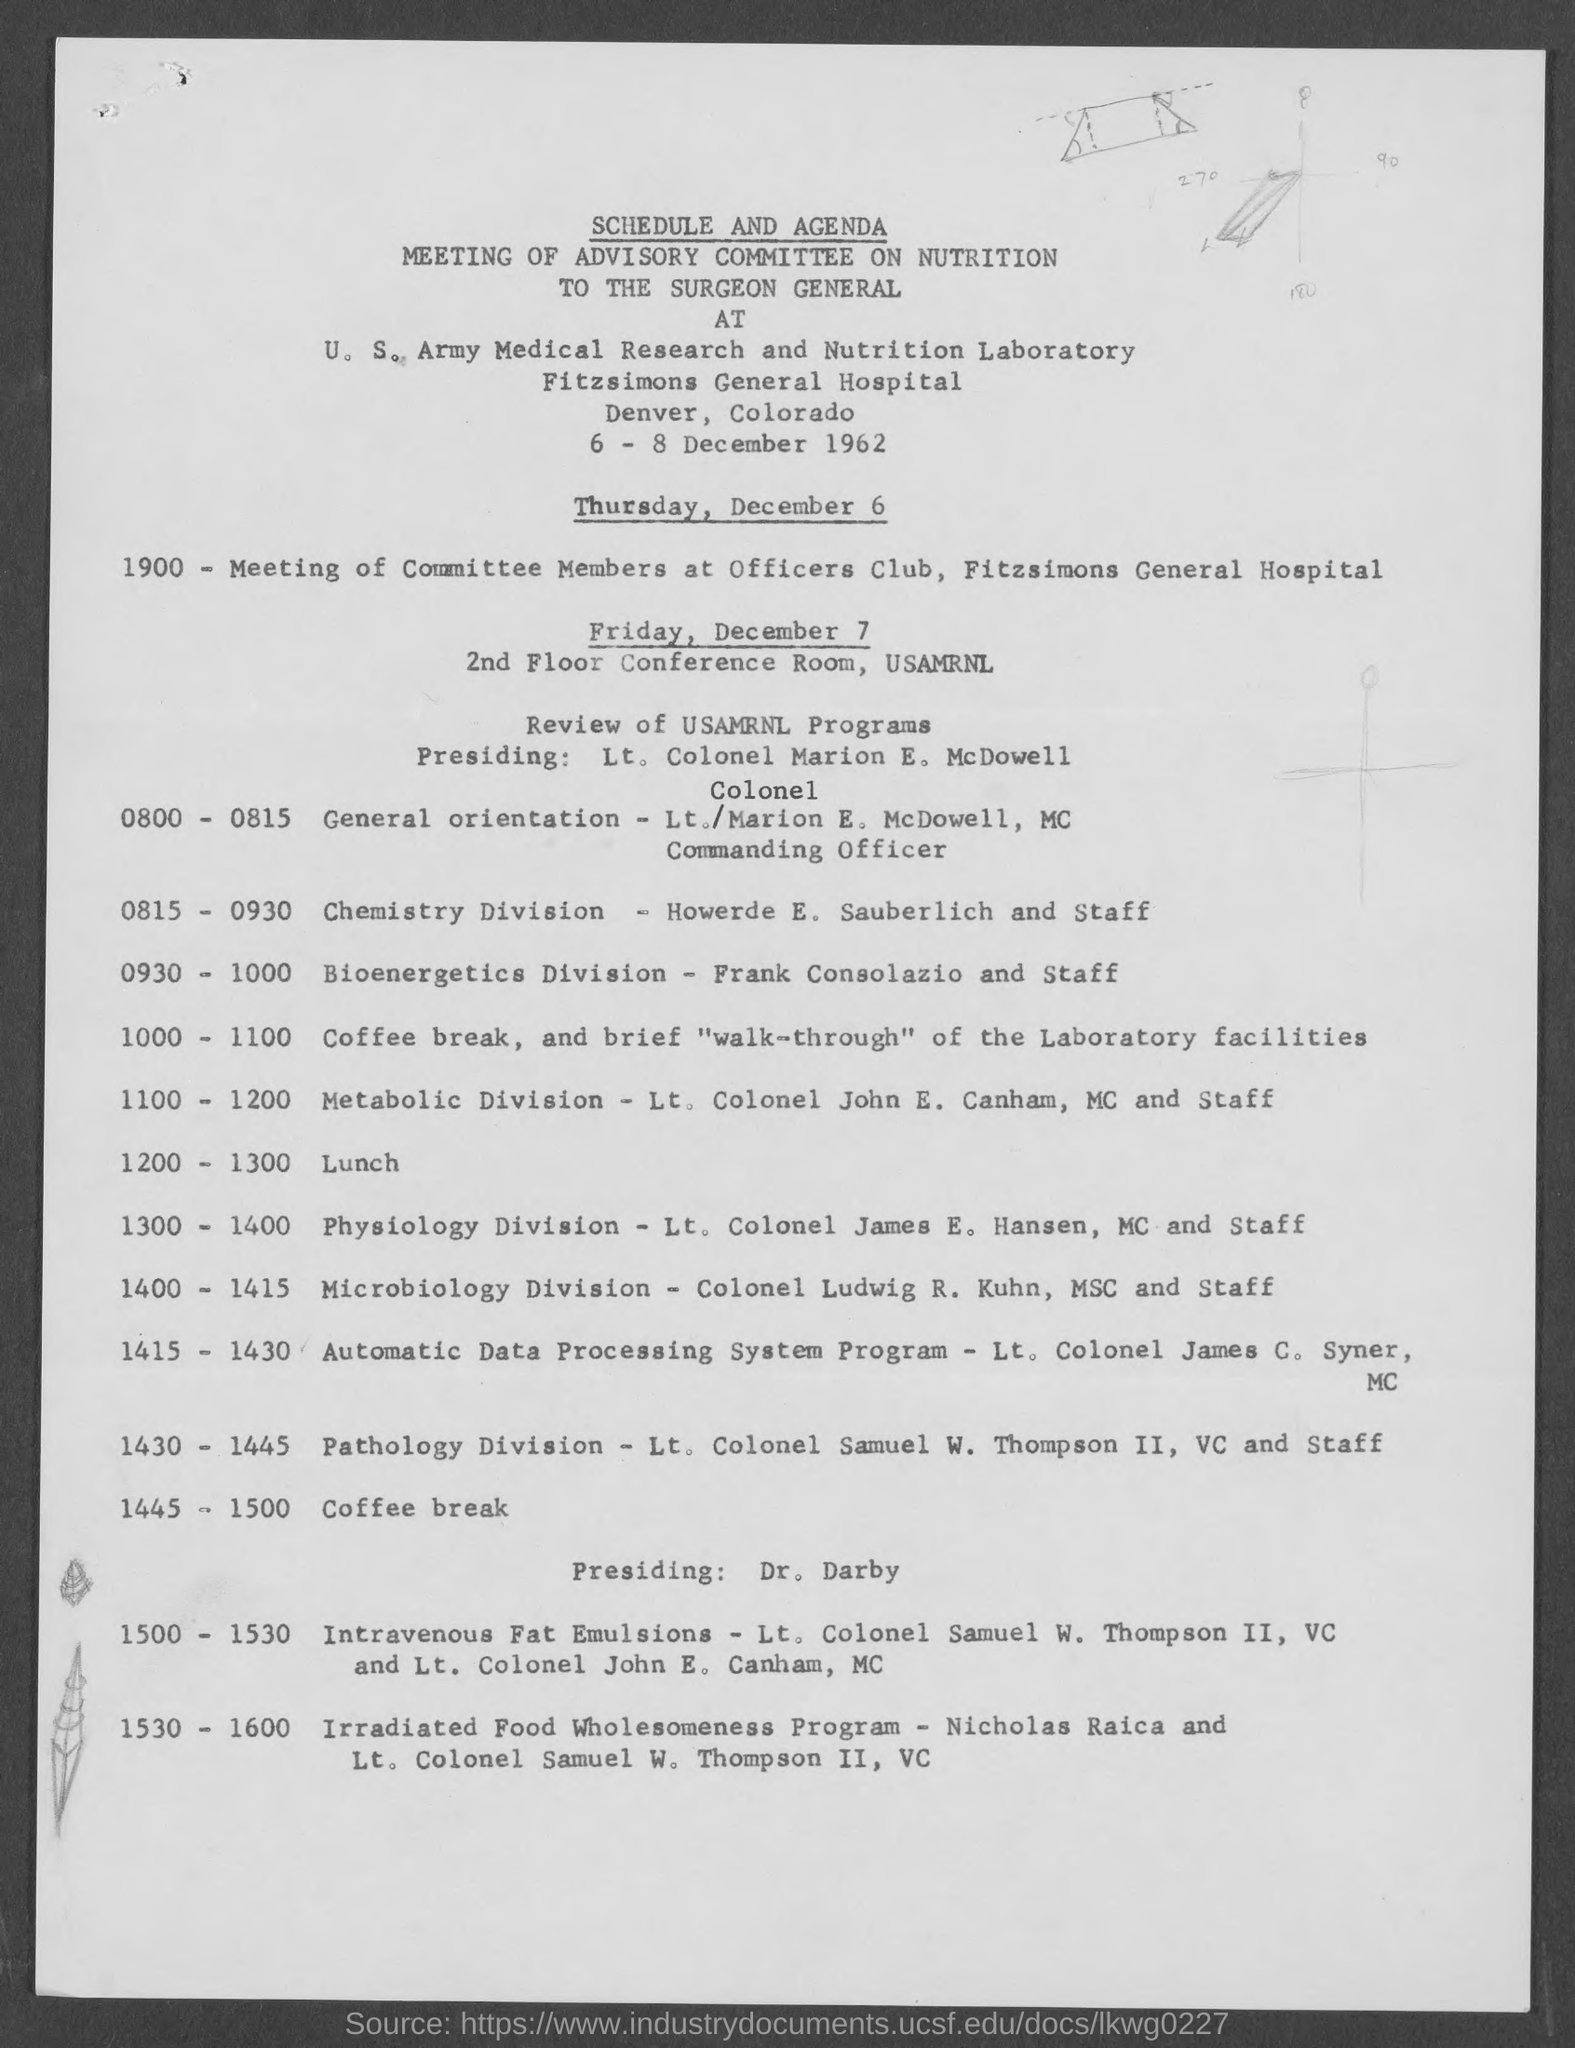Mention a couple of crucial points in this snapshot. Please provide the address for scheduling an appointment on Thursday, December 6, 2023, at Fitzsimons General Hospital. On Friday, December 7, the schedule will take place in the 2nd Floor conference room of USAMRNL. The heading of the document on top is 'Schedule and Agenda'. 